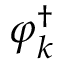<formula> <loc_0><loc_0><loc_500><loc_500>\varphi _ { k } ^ { \dagger }</formula> 